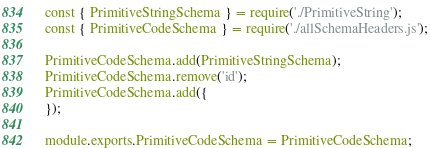Convert code to text. <code><loc_0><loc_0><loc_500><loc_500><_JavaScript_>const { PrimitiveStringSchema } = require('./PrimitiveString');
const { PrimitiveCodeSchema } = require('./allSchemaHeaders.js');

PrimitiveCodeSchema.add(PrimitiveStringSchema);
PrimitiveCodeSchema.remove('id');
PrimitiveCodeSchema.add({
});

module.exports.PrimitiveCodeSchema = PrimitiveCodeSchema;
</code> 